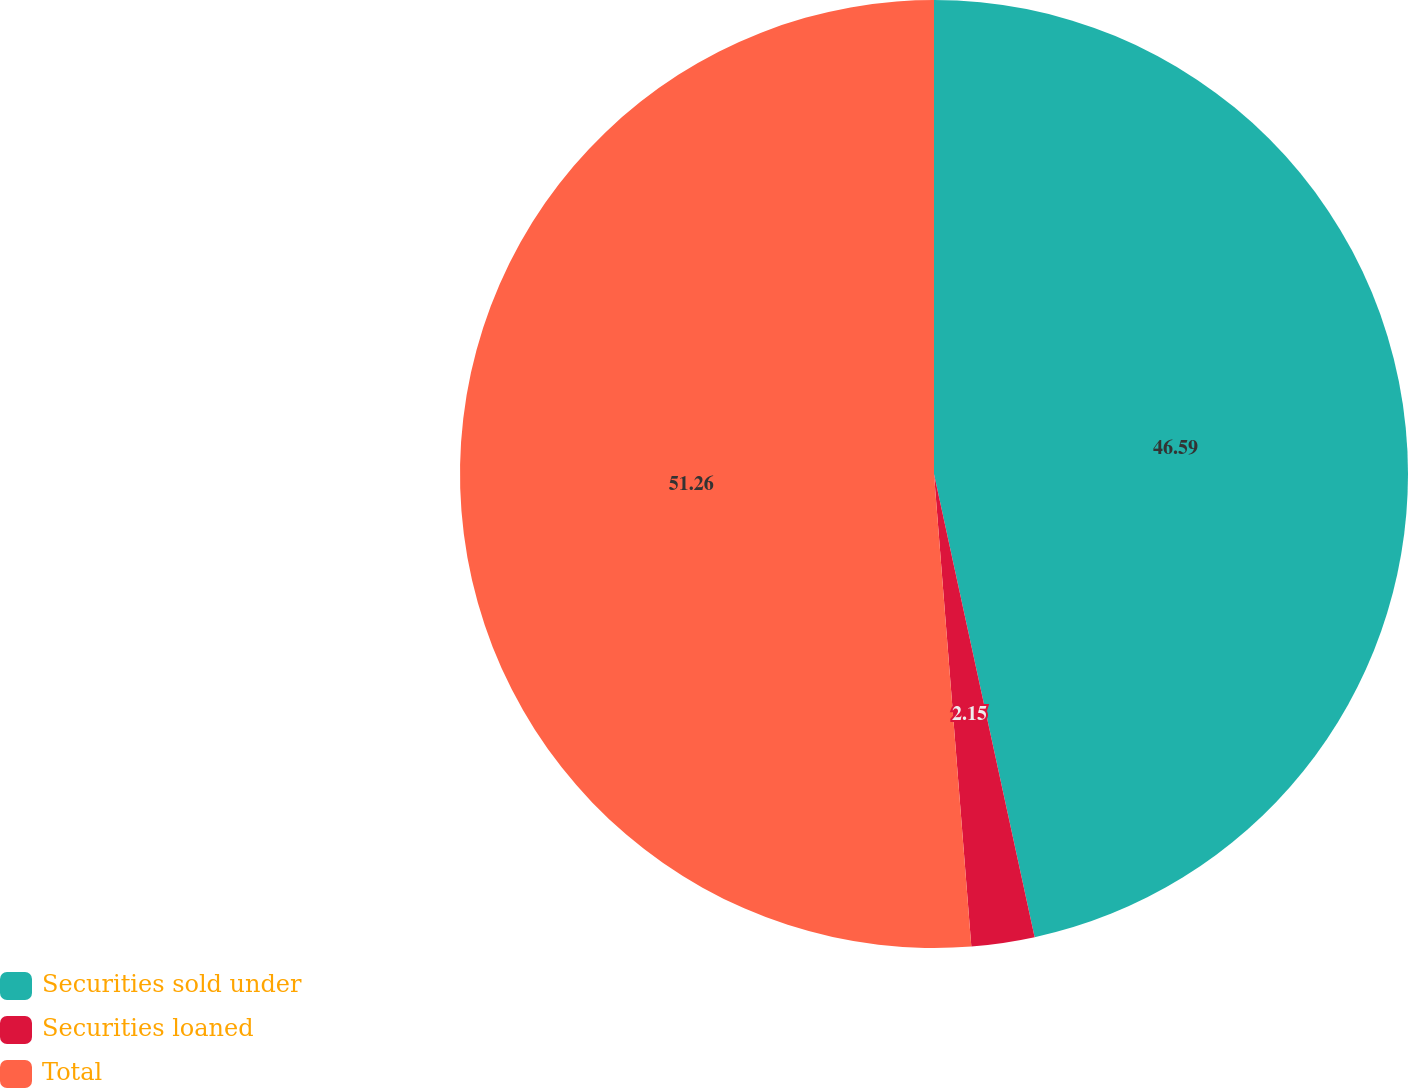Convert chart to OTSL. <chart><loc_0><loc_0><loc_500><loc_500><pie_chart><fcel>Securities sold under<fcel>Securities loaned<fcel>Total<nl><fcel>46.59%<fcel>2.15%<fcel>51.25%<nl></chart> 